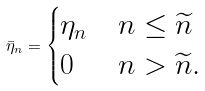<formula> <loc_0><loc_0><loc_500><loc_500>\bar { \eta } _ { n } = \begin{cases} \eta _ { n } & n \leq \widetilde { n } \\ 0 & n > \widetilde { n } . \end{cases}</formula> 